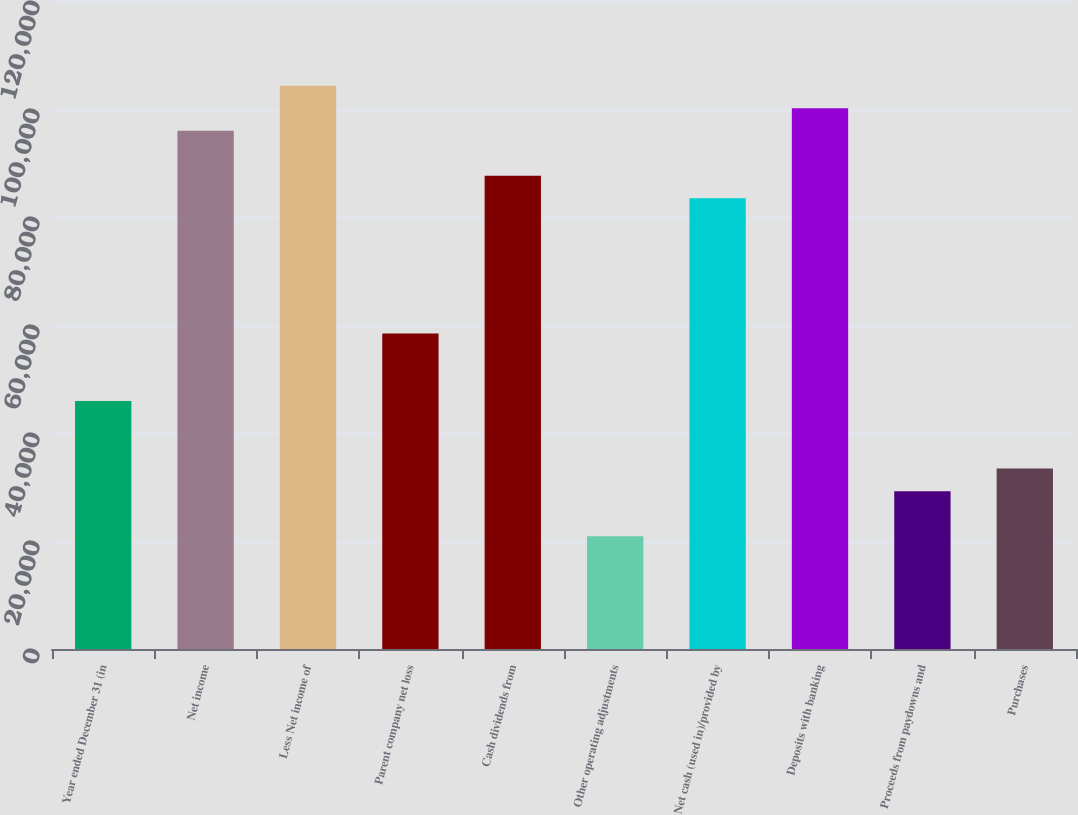Convert chart to OTSL. <chart><loc_0><loc_0><loc_500><loc_500><bar_chart><fcel>Year ended December 31 (in<fcel>Net income<fcel>Less Net income of<fcel>Parent company net loss<fcel>Cash dividends from<fcel>Other operating adjustments<fcel>Net cash (used in)/provided by<fcel>Deposits with banking<fcel>Proceeds from paydowns and<fcel>Purchases<nl><fcel>45918.8<fcel>95980.4<fcel>104324<fcel>58434.2<fcel>87636.8<fcel>20888<fcel>83465<fcel>100152<fcel>29231.6<fcel>33403.4<nl></chart> 